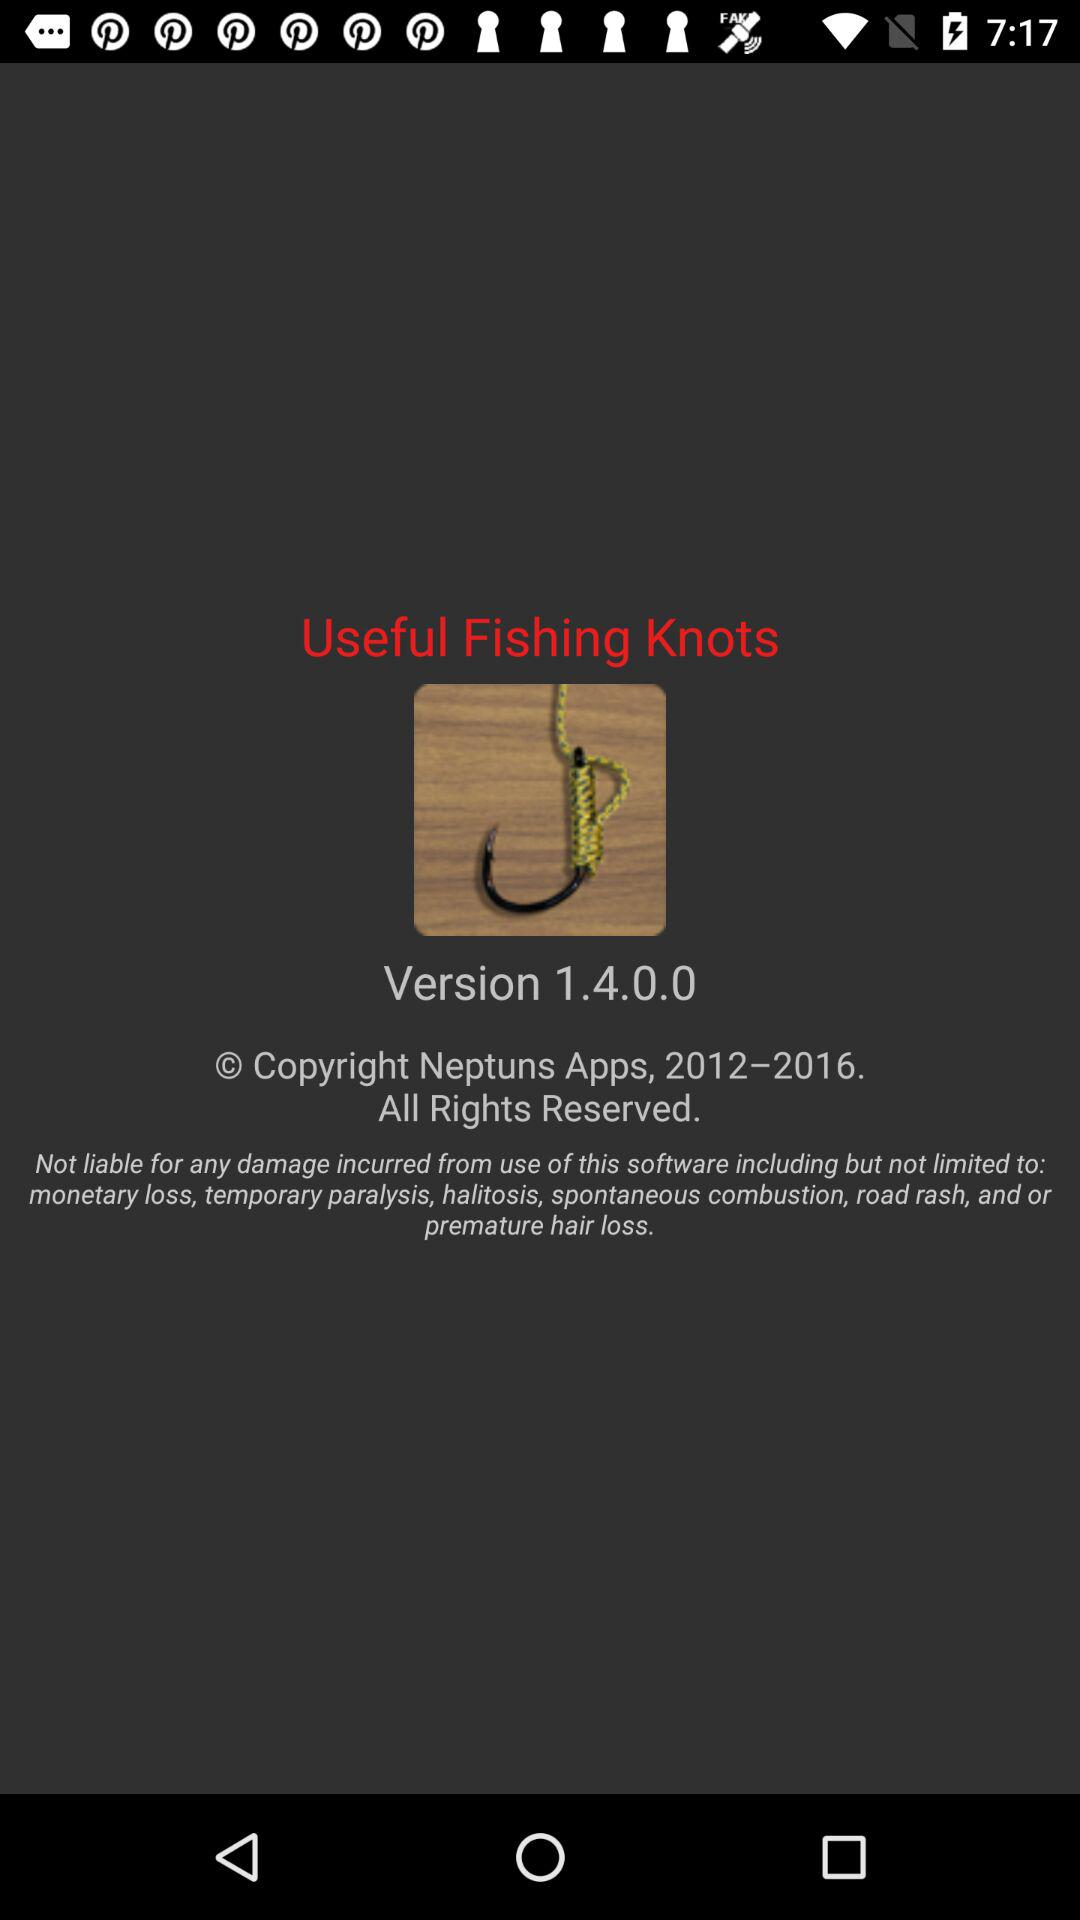What is the app's name? The app's name is "Useful Fishing Knots". 